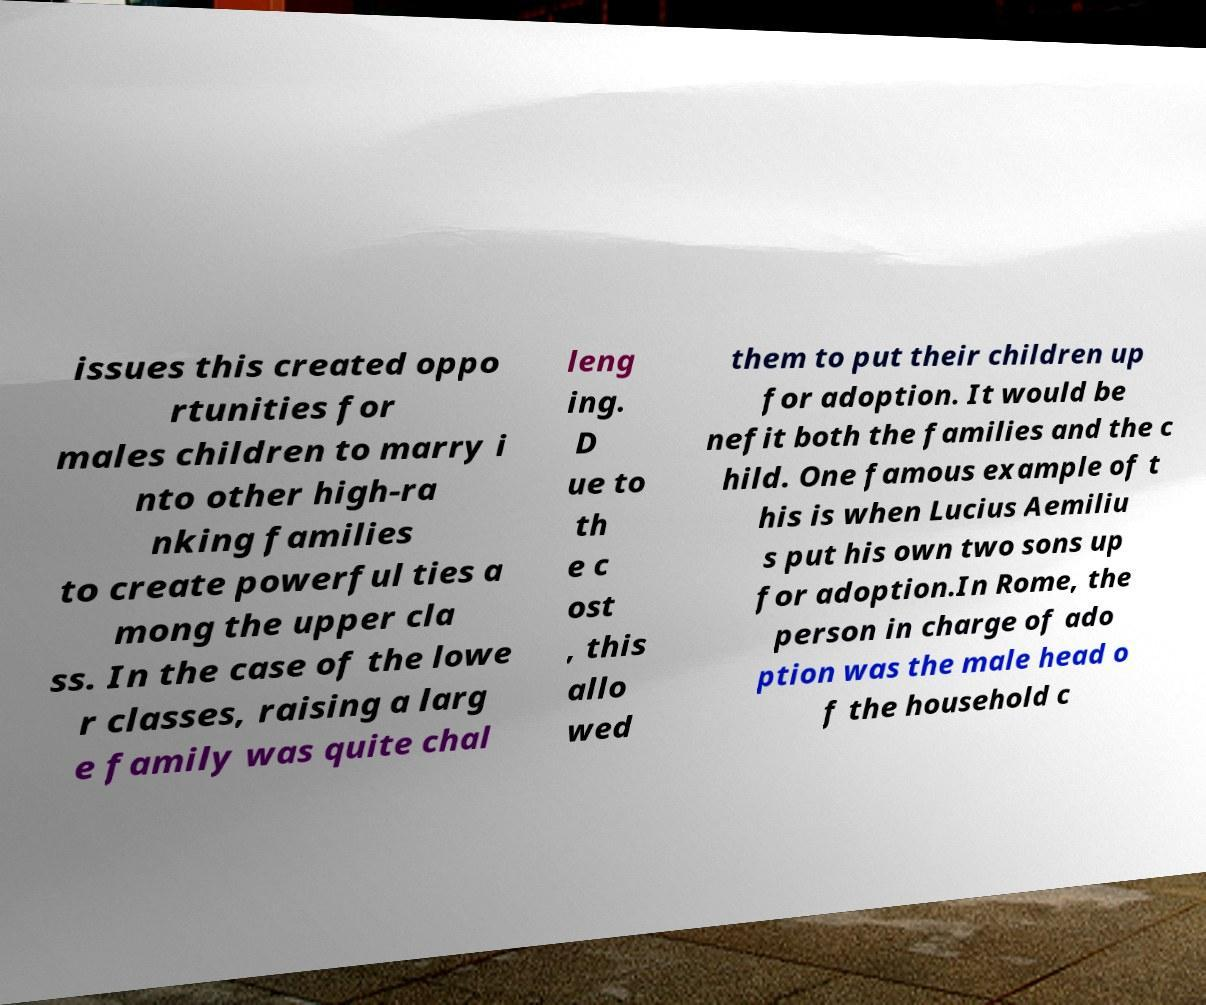There's text embedded in this image that I need extracted. Can you transcribe it verbatim? issues this created oppo rtunities for males children to marry i nto other high-ra nking families to create powerful ties a mong the upper cla ss. In the case of the lowe r classes, raising a larg e family was quite chal leng ing. D ue to th e c ost , this allo wed them to put their children up for adoption. It would be nefit both the families and the c hild. One famous example of t his is when Lucius Aemiliu s put his own two sons up for adoption.In Rome, the person in charge of ado ption was the male head o f the household c 